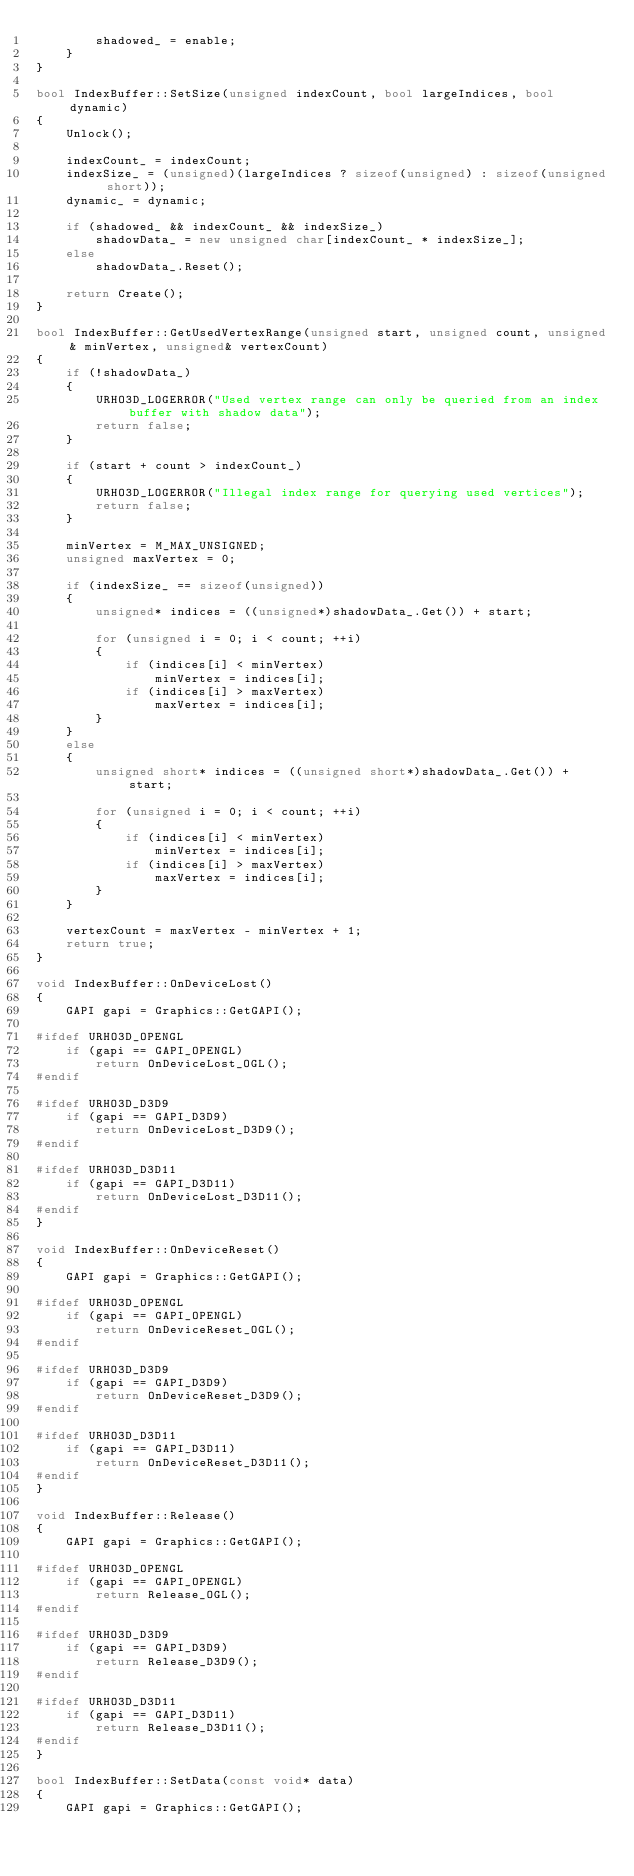<code> <loc_0><loc_0><loc_500><loc_500><_C++_>        shadowed_ = enable;
    }
}

bool IndexBuffer::SetSize(unsigned indexCount, bool largeIndices, bool dynamic)
{
    Unlock();

    indexCount_ = indexCount;
    indexSize_ = (unsigned)(largeIndices ? sizeof(unsigned) : sizeof(unsigned short));
    dynamic_ = dynamic;

    if (shadowed_ && indexCount_ && indexSize_)
        shadowData_ = new unsigned char[indexCount_ * indexSize_];
    else
        shadowData_.Reset();

    return Create();
}

bool IndexBuffer::GetUsedVertexRange(unsigned start, unsigned count, unsigned& minVertex, unsigned& vertexCount)
{
    if (!shadowData_)
    {
        URHO3D_LOGERROR("Used vertex range can only be queried from an index buffer with shadow data");
        return false;
    }

    if (start + count > indexCount_)
    {
        URHO3D_LOGERROR("Illegal index range for querying used vertices");
        return false;
    }

    minVertex = M_MAX_UNSIGNED;
    unsigned maxVertex = 0;

    if (indexSize_ == sizeof(unsigned))
    {
        unsigned* indices = ((unsigned*)shadowData_.Get()) + start;

        for (unsigned i = 0; i < count; ++i)
        {
            if (indices[i] < minVertex)
                minVertex = indices[i];
            if (indices[i] > maxVertex)
                maxVertex = indices[i];
        }
    }
    else
    {
        unsigned short* indices = ((unsigned short*)shadowData_.Get()) + start;

        for (unsigned i = 0; i < count; ++i)
        {
            if (indices[i] < minVertex)
                minVertex = indices[i];
            if (indices[i] > maxVertex)
                maxVertex = indices[i];
        }
    }

    vertexCount = maxVertex - minVertex + 1;
    return true;
}

void IndexBuffer::OnDeviceLost()
{
    GAPI gapi = Graphics::GetGAPI();

#ifdef URHO3D_OPENGL
    if (gapi == GAPI_OPENGL)
        return OnDeviceLost_OGL();
#endif

#ifdef URHO3D_D3D9
    if (gapi == GAPI_D3D9)
        return OnDeviceLost_D3D9();
#endif

#ifdef URHO3D_D3D11
    if (gapi == GAPI_D3D11)
        return OnDeviceLost_D3D11();
#endif
}

void IndexBuffer::OnDeviceReset()
{
    GAPI gapi = Graphics::GetGAPI();

#ifdef URHO3D_OPENGL
    if (gapi == GAPI_OPENGL)
        return OnDeviceReset_OGL();
#endif

#ifdef URHO3D_D3D9
    if (gapi == GAPI_D3D9)
        return OnDeviceReset_D3D9();
#endif

#ifdef URHO3D_D3D11
    if (gapi == GAPI_D3D11)
        return OnDeviceReset_D3D11();
#endif
}

void IndexBuffer::Release()
{
    GAPI gapi = Graphics::GetGAPI();

#ifdef URHO3D_OPENGL
    if (gapi == GAPI_OPENGL)
        return Release_OGL();
#endif

#ifdef URHO3D_D3D9
    if (gapi == GAPI_D3D9)
        return Release_D3D9();
#endif

#ifdef URHO3D_D3D11
    if (gapi == GAPI_D3D11)
        return Release_D3D11();
#endif
}

bool IndexBuffer::SetData(const void* data)
{
    GAPI gapi = Graphics::GetGAPI();
</code> 